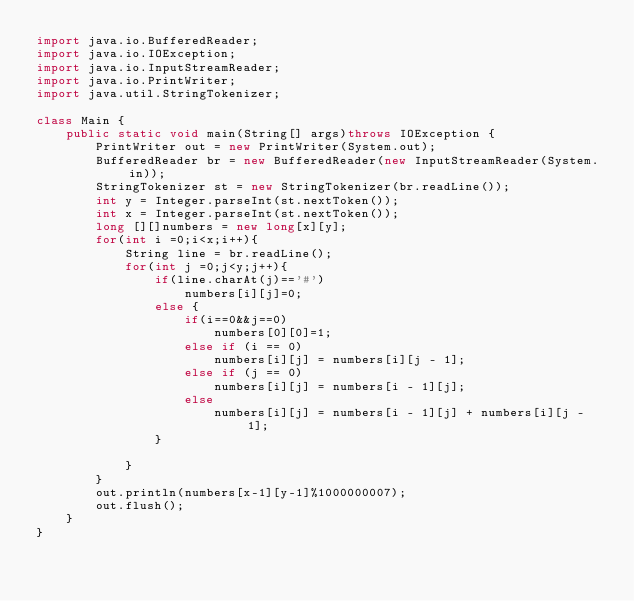<code> <loc_0><loc_0><loc_500><loc_500><_Java_>import java.io.BufferedReader;
import java.io.IOException;
import java.io.InputStreamReader;
import java.io.PrintWriter;
import java.util.StringTokenizer;

class Main {
    public static void main(String[] args)throws IOException {
        PrintWriter out = new PrintWriter(System.out);
        BufferedReader br = new BufferedReader(new InputStreamReader(System.in));
        StringTokenizer st = new StringTokenizer(br.readLine());
        int y = Integer.parseInt(st.nextToken());
        int x = Integer.parseInt(st.nextToken());
        long [][]numbers = new long[x][y];
        for(int i =0;i<x;i++){
            String line = br.readLine();
            for(int j =0;j<y;j++){
                if(line.charAt(j)=='#')
                    numbers[i][j]=0;
                else {
                    if(i==0&&j==0)
                        numbers[0][0]=1;
                    else if (i == 0)
                        numbers[i][j] = numbers[i][j - 1];
                    else if (j == 0)
                        numbers[i][j] = numbers[i - 1][j];
                    else
                        numbers[i][j] = numbers[i - 1][j] + numbers[i][j - 1];
                }

            }
        }
        out.println(numbers[x-1][y-1]%1000000007);
        out.flush();
    }
}</code> 